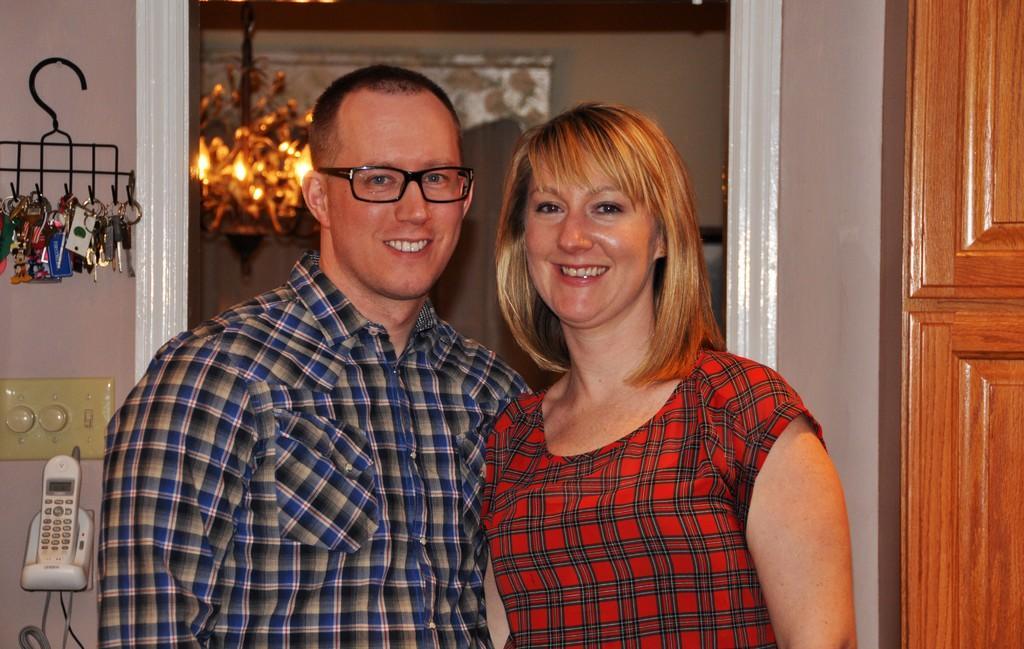In one or two sentences, can you explain what this image depicts? This picture is clicked inside the room. In the foreground we can see a woman and a man smiling and standing on the floor. On the right we can see a wooden object which seems to be the cabinet. On the left we can see the telephone and we can see the keys and some objects are hanging on the hanger and the hanger is hanging on the wall and we can see the switch board, cables. In the background we can see the wall, a chandelier seems to be hanging on the roof and we can see some other objects in the background. 